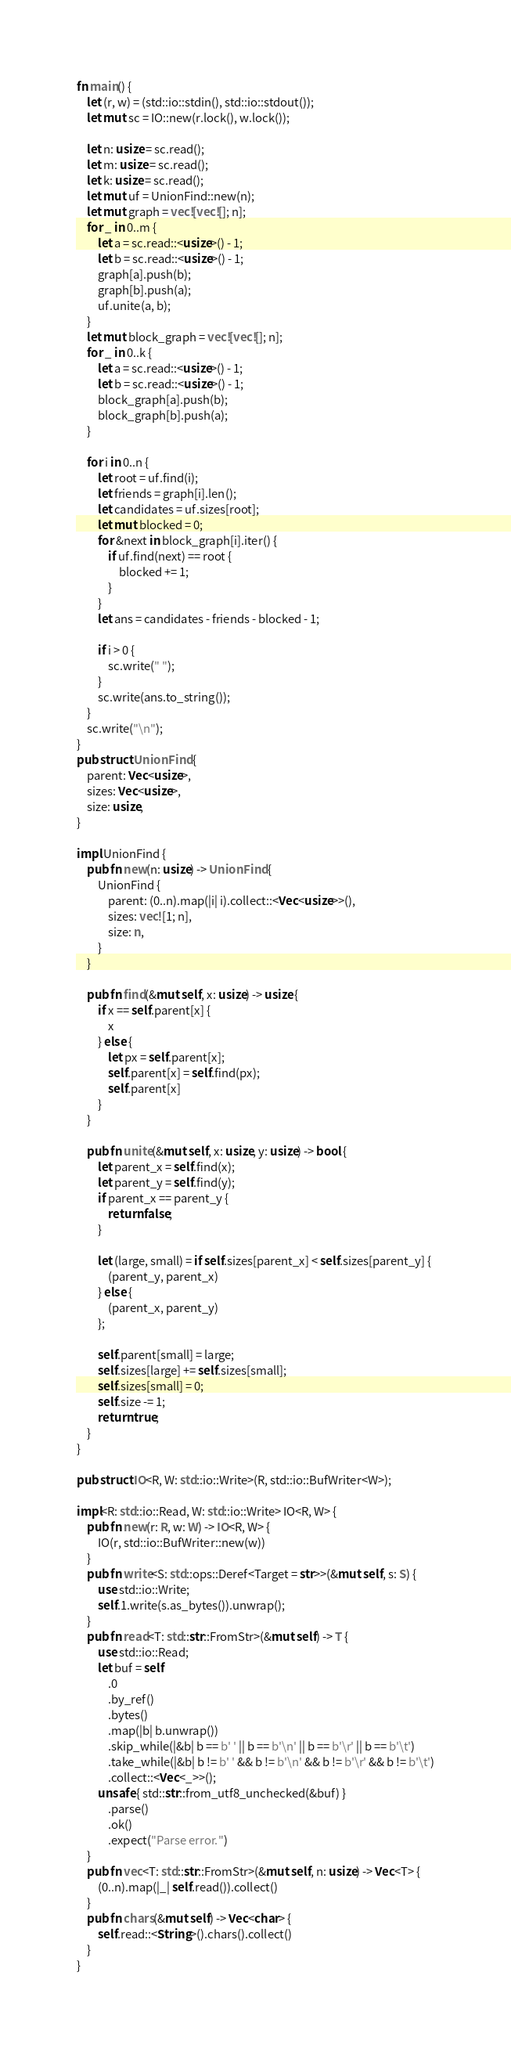<code> <loc_0><loc_0><loc_500><loc_500><_Rust_>fn main() {
    let (r, w) = (std::io::stdin(), std::io::stdout());
    let mut sc = IO::new(r.lock(), w.lock());

    let n: usize = sc.read();
    let m: usize = sc.read();
    let k: usize = sc.read();
    let mut uf = UnionFind::new(n);
    let mut graph = vec![vec![]; n];
    for _ in 0..m {
        let a = sc.read::<usize>() - 1;
        let b = sc.read::<usize>() - 1;
        graph[a].push(b);
        graph[b].push(a);
        uf.unite(a, b);
    }
    let mut block_graph = vec![vec![]; n];
    for _ in 0..k {
        let a = sc.read::<usize>() - 1;
        let b = sc.read::<usize>() - 1;
        block_graph[a].push(b);
        block_graph[b].push(a);
    }

    for i in 0..n {
        let root = uf.find(i);
        let friends = graph[i].len();
        let candidates = uf.sizes[root];
        let mut blocked = 0;
        for &next in block_graph[i].iter() {
            if uf.find(next) == root {
                blocked += 1;
            }
        }
        let ans = candidates - friends - blocked - 1;

        if i > 0 {
            sc.write(" ");
        }
        sc.write(ans.to_string());
    }
    sc.write("\n");
}
pub struct UnionFind {
    parent: Vec<usize>,
    sizes: Vec<usize>,
    size: usize,
}

impl UnionFind {
    pub fn new(n: usize) -> UnionFind {
        UnionFind {
            parent: (0..n).map(|i| i).collect::<Vec<usize>>(),
            sizes: vec![1; n],
            size: n,
        }
    }

    pub fn find(&mut self, x: usize) -> usize {
        if x == self.parent[x] {
            x
        } else {
            let px = self.parent[x];
            self.parent[x] = self.find(px);
            self.parent[x]
        }
    }

    pub fn unite(&mut self, x: usize, y: usize) -> bool {
        let parent_x = self.find(x);
        let parent_y = self.find(y);
        if parent_x == parent_y {
            return false;
        }

        let (large, small) = if self.sizes[parent_x] < self.sizes[parent_y] {
            (parent_y, parent_x)
        } else {
            (parent_x, parent_y)
        };

        self.parent[small] = large;
        self.sizes[large] += self.sizes[small];
        self.sizes[small] = 0;
        self.size -= 1;
        return true;
    }
}

pub struct IO<R, W: std::io::Write>(R, std::io::BufWriter<W>);

impl<R: std::io::Read, W: std::io::Write> IO<R, W> {
    pub fn new(r: R, w: W) -> IO<R, W> {
        IO(r, std::io::BufWriter::new(w))
    }
    pub fn write<S: std::ops::Deref<Target = str>>(&mut self, s: S) {
        use std::io::Write;
        self.1.write(s.as_bytes()).unwrap();
    }
    pub fn read<T: std::str::FromStr>(&mut self) -> T {
        use std::io::Read;
        let buf = self
            .0
            .by_ref()
            .bytes()
            .map(|b| b.unwrap())
            .skip_while(|&b| b == b' ' || b == b'\n' || b == b'\r' || b == b'\t')
            .take_while(|&b| b != b' ' && b != b'\n' && b != b'\r' && b != b'\t')
            .collect::<Vec<_>>();
        unsafe { std::str::from_utf8_unchecked(&buf) }
            .parse()
            .ok()
            .expect("Parse error.")
    }
    pub fn vec<T: std::str::FromStr>(&mut self, n: usize) -> Vec<T> {
        (0..n).map(|_| self.read()).collect()
    }
    pub fn chars(&mut self) -> Vec<char> {
        self.read::<String>().chars().collect()
    }
}
</code> 